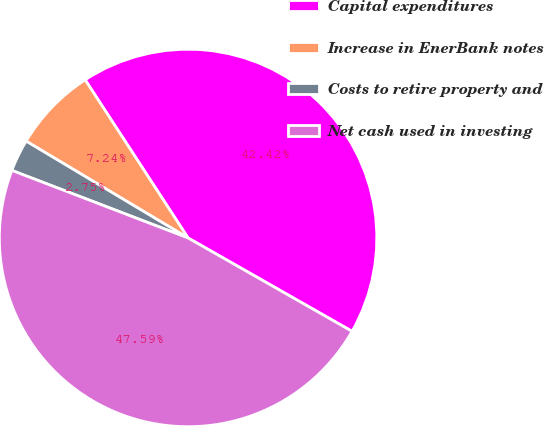<chart> <loc_0><loc_0><loc_500><loc_500><pie_chart><fcel>Capital expenditures<fcel>Increase in EnerBank notes<fcel>Costs to retire property and<fcel>Net cash used in investing<nl><fcel>42.42%<fcel>7.24%<fcel>2.75%<fcel>47.59%<nl></chart> 